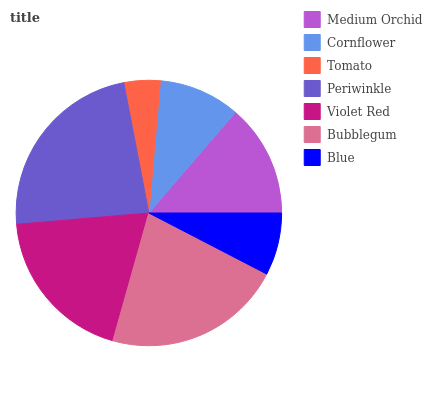Is Tomato the minimum?
Answer yes or no. Yes. Is Periwinkle the maximum?
Answer yes or no. Yes. Is Cornflower the minimum?
Answer yes or no. No. Is Cornflower the maximum?
Answer yes or no. No. Is Medium Orchid greater than Cornflower?
Answer yes or no. Yes. Is Cornflower less than Medium Orchid?
Answer yes or no. Yes. Is Cornflower greater than Medium Orchid?
Answer yes or no. No. Is Medium Orchid less than Cornflower?
Answer yes or no. No. Is Medium Orchid the high median?
Answer yes or no. Yes. Is Medium Orchid the low median?
Answer yes or no. Yes. Is Blue the high median?
Answer yes or no. No. Is Periwinkle the low median?
Answer yes or no. No. 